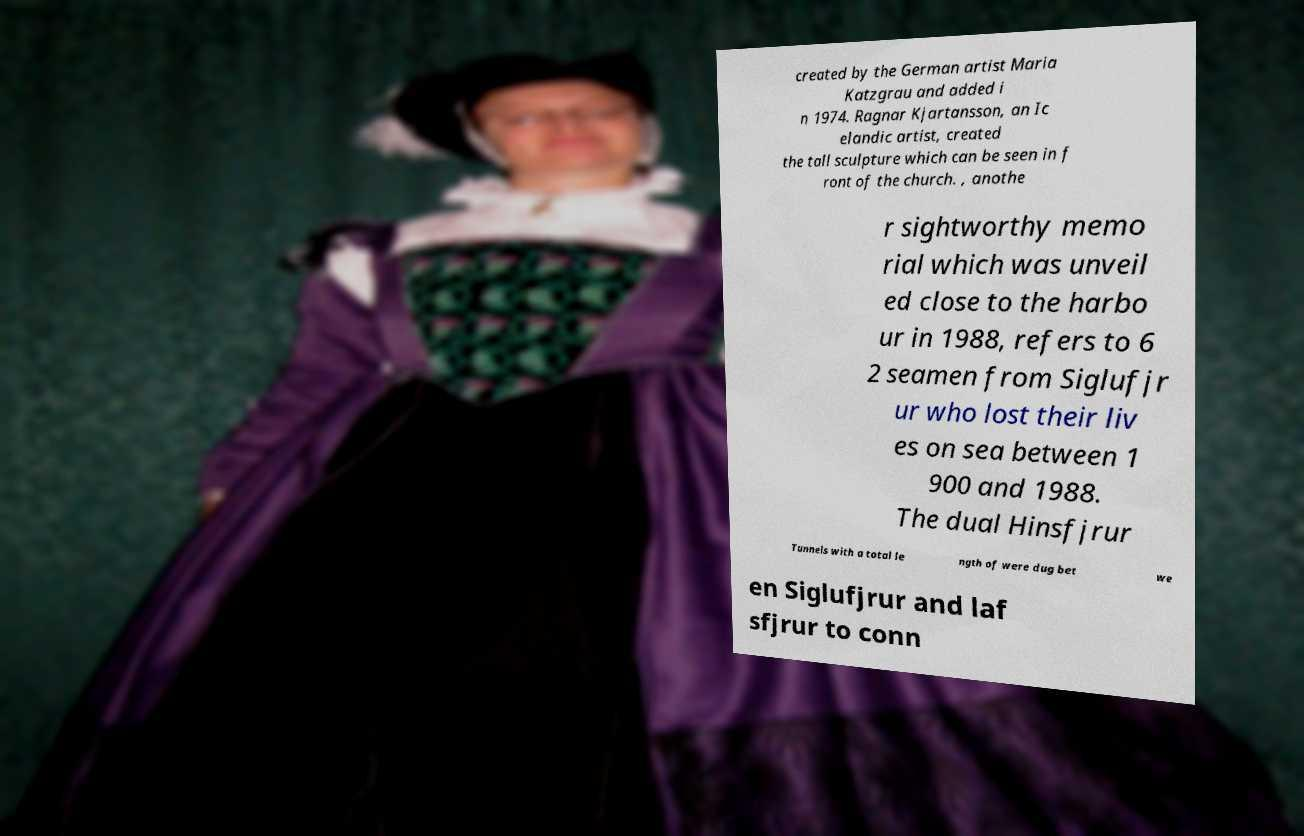Please read and relay the text visible in this image. What does it say? created by the German artist Maria Katzgrau and added i n 1974. Ragnar Kjartansson, an Ic elandic artist, created the tall sculpture which can be seen in f ront of the church. , anothe r sightworthy memo rial which was unveil ed close to the harbo ur in 1988, refers to 6 2 seamen from Siglufjr ur who lost their liv es on sea between 1 900 and 1988. The dual Hinsfjrur Tunnels with a total le ngth of were dug bet we en Siglufjrur and laf sfjrur to conn 